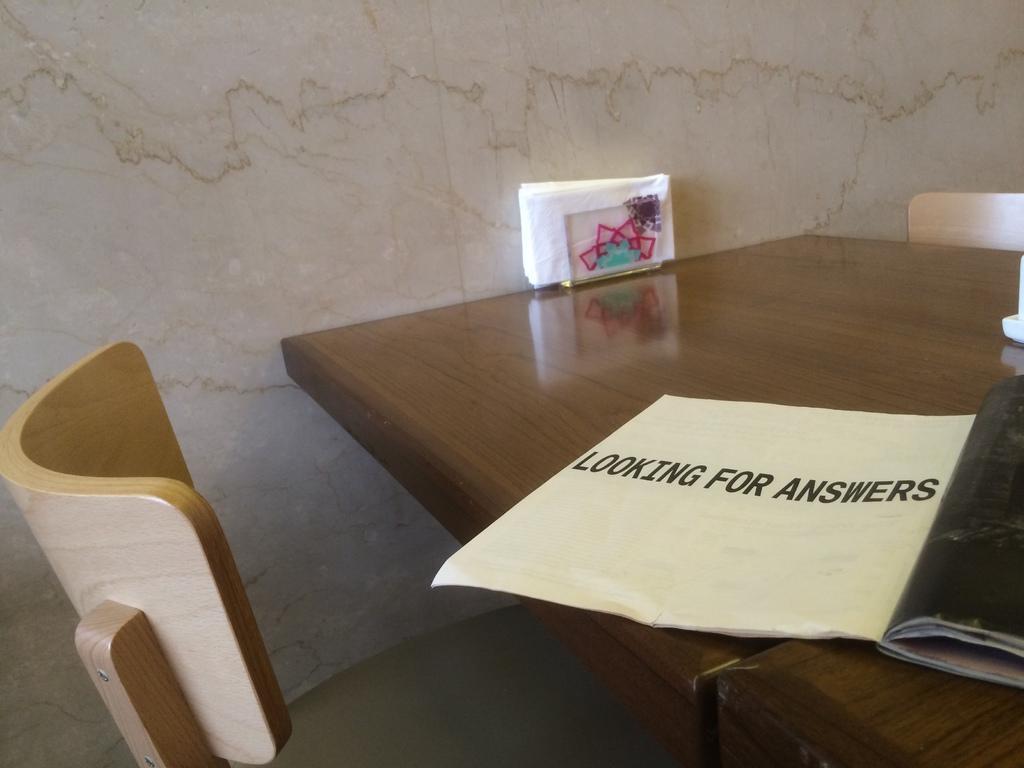Please provide a concise description of this image. In this image there are two tables and chairs, on the tables there are some tissue papers and some object and in the background there is a wall. 